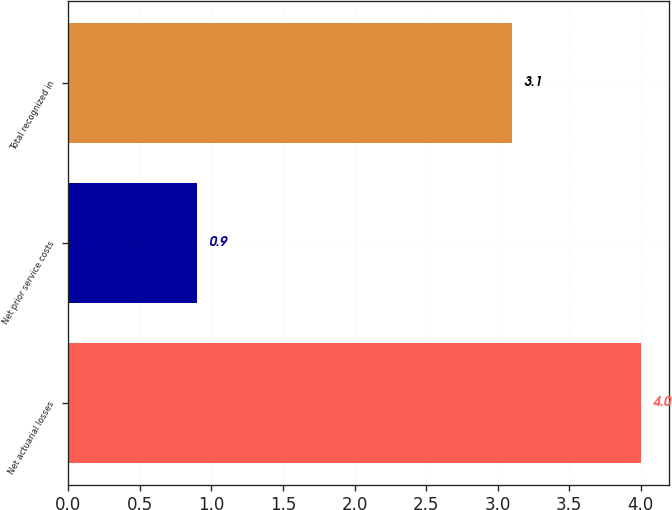<chart> <loc_0><loc_0><loc_500><loc_500><bar_chart><fcel>Net actuarial losses<fcel>Net prior service costs<fcel>Total recognized in<nl><fcel>4<fcel>0.9<fcel>3.1<nl></chart> 